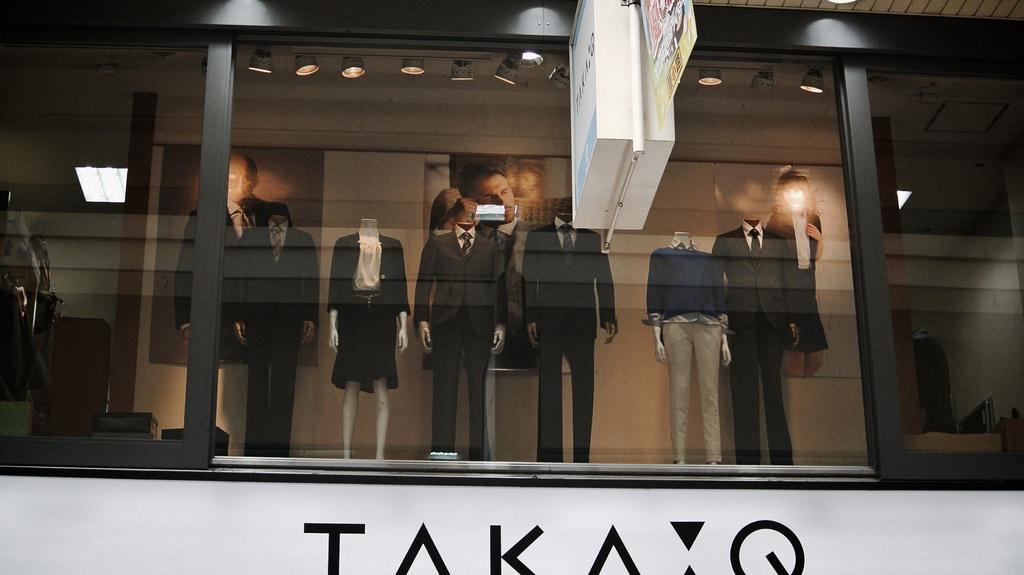In one or two sentences, can you explain what this image depicts? This image consists of a building. In which there are mannequins. It looks like a clothes shop. 